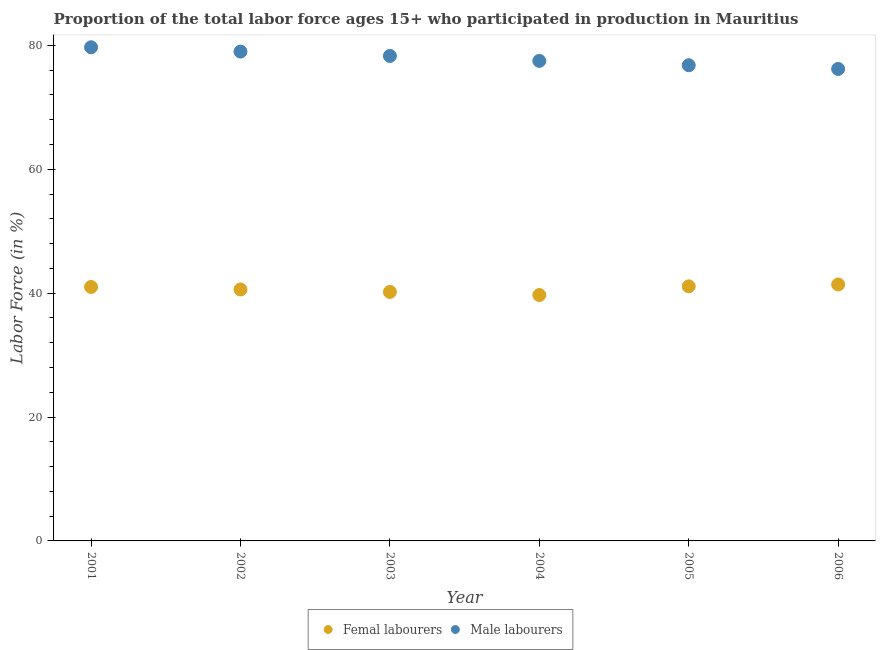Is the number of dotlines equal to the number of legend labels?
Offer a terse response. Yes. What is the percentage of female labor force in 2001?
Your answer should be compact. 41. Across all years, what is the maximum percentage of male labour force?
Your answer should be compact. 79.7. Across all years, what is the minimum percentage of male labour force?
Provide a short and direct response. 76.2. In which year was the percentage of male labour force minimum?
Your answer should be compact. 2006. What is the total percentage of female labor force in the graph?
Offer a terse response. 244. What is the difference between the percentage of female labor force in 2002 and that in 2003?
Your response must be concise. 0.4. What is the difference between the percentage of male labour force in 2006 and the percentage of female labor force in 2005?
Make the answer very short. 35.1. What is the average percentage of female labor force per year?
Your answer should be compact. 40.67. In the year 2001, what is the difference between the percentage of male labour force and percentage of female labor force?
Offer a very short reply. 38.7. In how many years, is the percentage of male labour force greater than 32 %?
Your answer should be very brief. 6. What is the ratio of the percentage of female labor force in 2003 to that in 2006?
Keep it short and to the point. 0.97. What is the difference between the highest and the second highest percentage of male labour force?
Keep it short and to the point. 0.7. What is the difference between the highest and the lowest percentage of female labor force?
Ensure brevity in your answer.  1.7. In how many years, is the percentage of female labor force greater than the average percentage of female labor force taken over all years?
Offer a very short reply. 3. Does the percentage of female labor force monotonically increase over the years?
Give a very brief answer. No. How many years are there in the graph?
Ensure brevity in your answer.  6. What is the difference between two consecutive major ticks on the Y-axis?
Make the answer very short. 20. Are the values on the major ticks of Y-axis written in scientific E-notation?
Your response must be concise. No. Does the graph contain grids?
Offer a very short reply. No. Where does the legend appear in the graph?
Your response must be concise. Bottom center. How many legend labels are there?
Make the answer very short. 2. What is the title of the graph?
Ensure brevity in your answer.  Proportion of the total labor force ages 15+ who participated in production in Mauritius. Does "Savings" appear as one of the legend labels in the graph?
Provide a succinct answer. No. What is the Labor Force (in %) in Male labourers in 2001?
Provide a succinct answer. 79.7. What is the Labor Force (in %) in Femal labourers in 2002?
Make the answer very short. 40.6. What is the Labor Force (in %) of Male labourers in 2002?
Offer a terse response. 79. What is the Labor Force (in %) of Femal labourers in 2003?
Your answer should be compact. 40.2. What is the Labor Force (in %) in Male labourers in 2003?
Make the answer very short. 78.3. What is the Labor Force (in %) in Femal labourers in 2004?
Give a very brief answer. 39.7. What is the Labor Force (in %) in Male labourers in 2004?
Make the answer very short. 77.5. What is the Labor Force (in %) of Femal labourers in 2005?
Offer a terse response. 41.1. What is the Labor Force (in %) of Male labourers in 2005?
Provide a succinct answer. 76.8. What is the Labor Force (in %) of Femal labourers in 2006?
Give a very brief answer. 41.4. What is the Labor Force (in %) in Male labourers in 2006?
Give a very brief answer. 76.2. Across all years, what is the maximum Labor Force (in %) in Femal labourers?
Your response must be concise. 41.4. Across all years, what is the maximum Labor Force (in %) in Male labourers?
Keep it short and to the point. 79.7. Across all years, what is the minimum Labor Force (in %) in Femal labourers?
Your answer should be compact. 39.7. Across all years, what is the minimum Labor Force (in %) of Male labourers?
Offer a terse response. 76.2. What is the total Labor Force (in %) of Femal labourers in the graph?
Provide a succinct answer. 244. What is the total Labor Force (in %) of Male labourers in the graph?
Offer a very short reply. 467.5. What is the difference between the Labor Force (in %) in Male labourers in 2001 and that in 2002?
Ensure brevity in your answer.  0.7. What is the difference between the Labor Force (in %) in Femal labourers in 2001 and that in 2004?
Your response must be concise. 1.3. What is the difference between the Labor Force (in %) of Femal labourers in 2001 and that in 2005?
Provide a short and direct response. -0.1. What is the difference between the Labor Force (in %) of Male labourers in 2001 and that in 2006?
Your response must be concise. 3.5. What is the difference between the Labor Force (in %) of Femal labourers in 2002 and that in 2004?
Provide a short and direct response. 0.9. What is the difference between the Labor Force (in %) of Male labourers in 2002 and that in 2006?
Give a very brief answer. 2.8. What is the difference between the Labor Force (in %) in Femal labourers in 2003 and that in 2004?
Provide a succinct answer. 0.5. What is the difference between the Labor Force (in %) of Male labourers in 2003 and that in 2005?
Your response must be concise. 1.5. What is the difference between the Labor Force (in %) of Femal labourers in 2003 and that in 2006?
Keep it short and to the point. -1.2. What is the difference between the Labor Force (in %) in Femal labourers in 2004 and that in 2005?
Ensure brevity in your answer.  -1.4. What is the difference between the Labor Force (in %) in Femal labourers in 2004 and that in 2006?
Keep it short and to the point. -1.7. What is the difference between the Labor Force (in %) in Male labourers in 2004 and that in 2006?
Provide a succinct answer. 1.3. What is the difference between the Labor Force (in %) in Femal labourers in 2005 and that in 2006?
Offer a terse response. -0.3. What is the difference between the Labor Force (in %) in Male labourers in 2005 and that in 2006?
Provide a succinct answer. 0.6. What is the difference between the Labor Force (in %) in Femal labourers in 2001 and the Labor Force (in %) in Male labourers in 2002?
Give a very brief answer. -38. What is the difference between the Labor Force (in %) in Femal labourers in 2001 and the Labor Force (in %) in Male labourers in 2003?
Offer a very short reply. -37.3. What is the difference between the Labor Force (in %) in Femal labourers in 2001 and the Labor Force (in %) in Male labourers in 2004?
Provide a succinct answer. -36.5. What is the difference between the Labor Force (in %) in Femal labourers in 2001 and the Labor Force (in %) in Male labourers in 2005?
Offer a very short reply. -35.8. What is the difference between the Labor Force (in %) of Femal labourers in 2001 and the Labor Force (in %) of Male labourers in 2006?
Ensure brevity in your answer.  -35.2. What is the difference between the Labor Force (in %) of Femal labourers in 2002 and the Labor Force (in %) of Male labourers in 2003?
Your answer should be compact. -37.7. What is the difference between the Labor Force (in %) in Femal labourers in 2002 and the Labor Force (in %) in Male labourers in 2004?
Provide a succinct answer. -36.9. What is the difference between the Labor Force (in %) of Femal labourers in 2002 and the Labor Force (in %) of Male labourers in 2005?
Keep it short and to the point. -36.2. What is the difference between the Labor Force (in %) of Femal labourers in 2002 and the Labor Force (in %) of Male labourers in 2006?
Provide a succinct answer. -35.6. What is the difference between the Labor Force (in %) of Femal labourers in 2003 and the Labor Force (in %) of Male labourers in 2004?
Offer a terse response. -37.3. What is the difference between the Labor Force (in %) in Femal labourers in 2003 and the Labor Force (in %) in Male labourers in 2005?
Your answer should be compact. -36.6. What is the difference between the Labor Force (in %) of Femal labourers in 2003 and the Labor Force (in %) of Male labourers in 2006?
Provide a succinct answer. -36. What is the difference between the Labor Force (in %) of Femal labourers in 2004 and the Labor Force (in %) of Male labourers in 2005?
Your response must be concise. -37.1. What is the difference between the Labor Force (in %) of Femal labourers in 2004 and the Labor Force (in %) of Male labourers in 2006?
Your response must be concise. -36.5. What is the difference between the Labor Force (in %) of Femal labourers in 2005 and the Labor Force (in %) of Male labourers in 2006?
Make the answer very short. -35.1. What is the average Labor Force (in %) in Femal labourers per year?
Your answer should be compact. 40.67. What is the average Labor Force (in %) in Male labourers per year?
Ensure brevity in your answer.  77.92. In the year 2001, what is the difference between the Labor Force (in %) of Femal labourers and Labor Force (in %) of Male labourers?
Offer a very short reply. -38.7. In the year 2002, what is the difference between the Labor Force (in %) of Femal labourers and Labor Force (in %) of Male labourers?
Your response must be concise. -38.4. In the year 2003, what is the difference between the Labor Force (in %) of Femal labourers and Labor Force (in %) of Male labourers?
Provide a short and direct response. -38.1. In the year 2004, what is the difference between the Labor Force (in %) of Femal labourers and Labor Force (in %) of Male labourers?
Make the answer very short. -37.8. In the year 2005, what is the difference between the Labor Force (in %) of Femal labourers and Labor Force (in %) of Male labourers?
Provide a succinct answer. -35.7. In the year 2006, what is the difference between the Labor Force (in %) of Femal labourers and Labor Force (in %) of Male labourers?
Offer a terse response. -34.8. What is the ratio of the Labor Force (in %) in Femal labourers in 2001 to that in 2002?
Ensure brevity in your answer.  1.01. What is the ratio of the Labor Force (in %) of Male labourers in 2001 to that in 2002?
Your answer should be compact. 1.01. What is the ratio of the Labor Force (in %) of Femal labourers in 2001 to that in 2003?
Your response must be concise. 1.02. What is the ratio of the Labor Force (in %) in Male labourers in 2001 to that in 2003?
Provide a short and direct response. 1.02. What is the ratio of the Labor Force (in %) of Femal labourers in 2001 to that in 2004?
Your answer should be compact. 1.03. What is the ratio of the Labor Force (in %) in Male labourers in 2001 to that in 2004?
Keep it short and to the point. 1.03. What is the ratio of the Labor Force (in %) in Male labourers in 2001 to that in 2005?
Ensure brevity in your answer.  1.04. What is the ratio of the Labor Force (in %) of Femal labourers in 2001 to that in 2006?
Your answer should be compact. 0.99. What is the ratio of the Labor Force (in %) in Male labourers in 2001 to that in 2006?
Offer a terse response. 1.05. What is the ratio of the Labor Force (in %) in Male labourers in 2002 to that in 2003?
Provide a short and direct response. 1.01. What is the ratio of the Labor Force (in %) of Femal labourers in 2002 to that in 2004?
Ensure brevity in your answer.  1.02. What is the ratio of the Labor Force (in %) in Male labourers in 2002 to that in 2004?
Your response must be concise. 1.02. What is the ratio of the Labor Force (in %) of Femal labourers in 2002 to that in 2005?
Give a very brief answer. 0.99. What is the ratio of the Labor Force (in %) in Male labourers in 2002 to that in 2005?
Ensure brevity in your answer.  1.03. What is the ratio of the Labor Force (in %) in Femal labourers in 2002 to that in 2006?
Ensure brevity in your answer.  0.98. What is the ratio of the Labor Force (in %) in Male labourers in 2002 to that in 2006?
Your answer should be very brief. 1.04. What is the ratio of the Labor Force (in %) in Femal labourers in 2003 to that in 2004?
Offer a very short reply. 1.01. What is the ratio of the Labor Force (in %) in Male labourers in 2003 to that in 2004?
Keep it short and to the point. 1.01. What is the ratio of the Labor Force (in %) of Femal labourers in 2003 to that in 2005?
Offer a terse response. 0.98. What is the ratio of the Labor Force (in %) of Male labourers in 2003 to that in 2005?
Keep it short and to the point. 1.02. What is the ratio of the Labor Force (in %) in Male labourers in 2003 to that in 2006?
Make the answer very short. 1.03. What is the ratio of the Labor Force (in %) of Femal labourers in 2004 to that in 2005?
Keep it short and to the point. 0.97. What is the ratio of the Labor Force (in %) of Male labourers in 2004 to that in 2005?
Keep it short and to the point. 1.01. What is the ratio of the Labor Force (in %) in Femal labourers in 2004 to that in 2006?
Give a very brief answer. 0.96. What is the ratio of the Labor Force (in %) in Male labourers in 2004 to that in 2006?
Your answer should be compact. 1.02. What is the ratio of the Labor Force (in %) of Male labourers in 2005 to that in 2006?
Provide a succinct answer. 1.01. What is the difference between the highest and the second highest Labor Force (in %) of Femal labourers?
Provide a short and direct response. 0.3. What is the difference between the highest and the lowest Labor Force (in %) in Male labourers?
Provide a succinct answer. 3.5. 